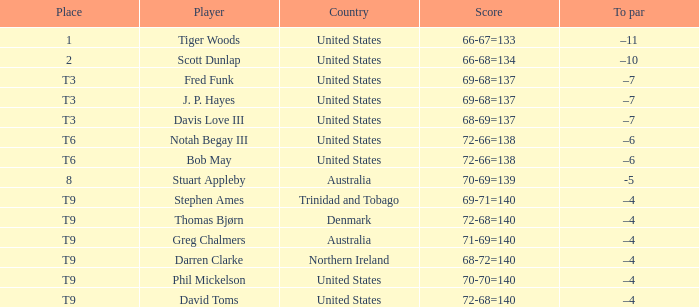What is the To par value that goes with a Score of 70-69=139? -5.0. 